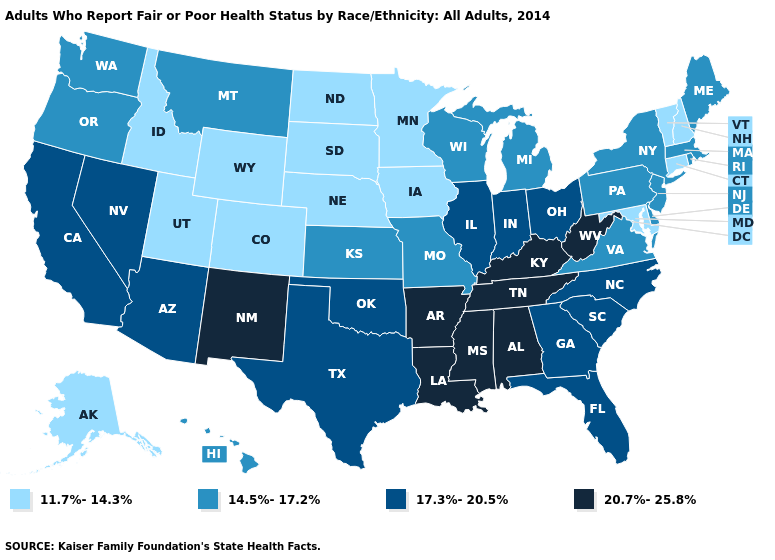Which states have the lowest value in the West?
Answer briefly. Alaska, Colorado, Idaho, Utah, Wyoming. What is the lowest value in states that border Maryland?
Be succinct. 14.5%-17.2%. Does Illinois have the highest value in the MidWest?
Concise answer only. Yes. What is the value of Tennessee?
Quick response, please. 20.7%-25.8%. What is the highest value in the Northeast ?
Keep it brief. 14.5%-17.2%. What is the value of Texas?
Give a very brief answer. 17.3%-20.5%. Among the states that border South Dakota , which have the highest value?
Be succinct. Montana. Is the legend a continuous bar?
Give a very brief answer. No. What is the highest value in states that border Utah?
Be succinct. 20.7%-25.8%. What is the highest value in states that border Arizona?
Short answer required. 20.7%-25.8%. Name the states that have a value in the range 20.7%-25.8%?
Give a very brief answer. Alabama, Arkansas, Kentucky, Louisiana, Mississippi, New Mexico, Tennessee, West Virginia. What is the value of Rhode Island?
Be succinct. 14.5%-17.2%. What is the lowest value in the USA?
Concise answer only. 11.7%-14.3%. Does the first symbol in the legend represent the smallest category?
Give a very brief answer. Yes. Name the states that have a value in the range 20.7%-25.8%?
Be succinct. Alabama, Arkansas, Kentucky, Louisiana, Mississippi, New Mexico, Tennessee, West Virginia. 